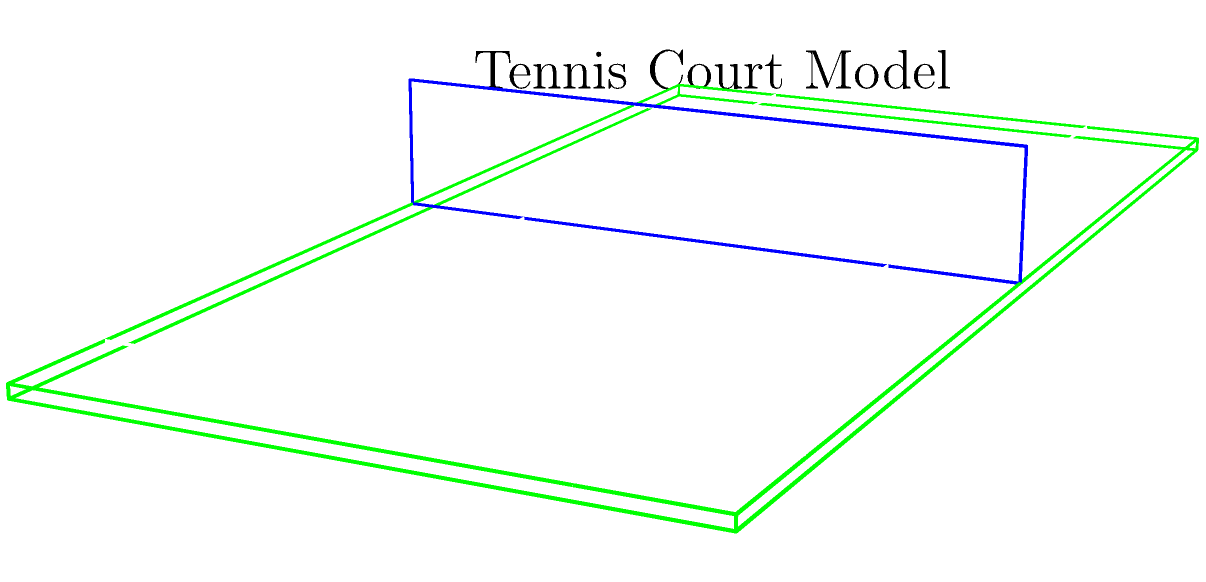As a doubles player familiar with the tennis court layout, consider a simplified 3D model of a tennis court as shown. The model consists of a rectangular prism for the court surface, a thin rectangular prism for the net, and white lines drawn on the surface. Calculate the Euler characteristic ($\chi$) of this model. Assume the net is connected to the court surface and the lines are part of the surface. Let's approach this step-by-step:

1) Recall the Euler characteristic formula: $\chi = V - E + F$, where V is the number of vertices, E is the number of edges, and F is the number of faces.

2) For the court surface (rectangular prism):
   - Vertices: 8
   - Edges: 12
   - Faces: 6

3) For the net (thin rectangular prism):
   - New vertices: 4 (top of the net)
   - New edges: 8 (4 vertical edges + 4 edges at the top)
   - New faces: 5 (4 sides + 1 top)

4) The lines on the court don't add to the Euler characteristic as they're part of the surface.

5) Total count:
   - Vertices: $V = 8 + 4 = 12$
   - Edges: $E = 12 + 8 = 20$
   - Faces: $F = 6 + 5 = 11$

6) Applying the formula:
   $\chi = V - E + F = 12 - 20 + 11 = 3$

The Euler characteristic of this simplified tennis court model is 3.
Answer: $\chi = 3$ 